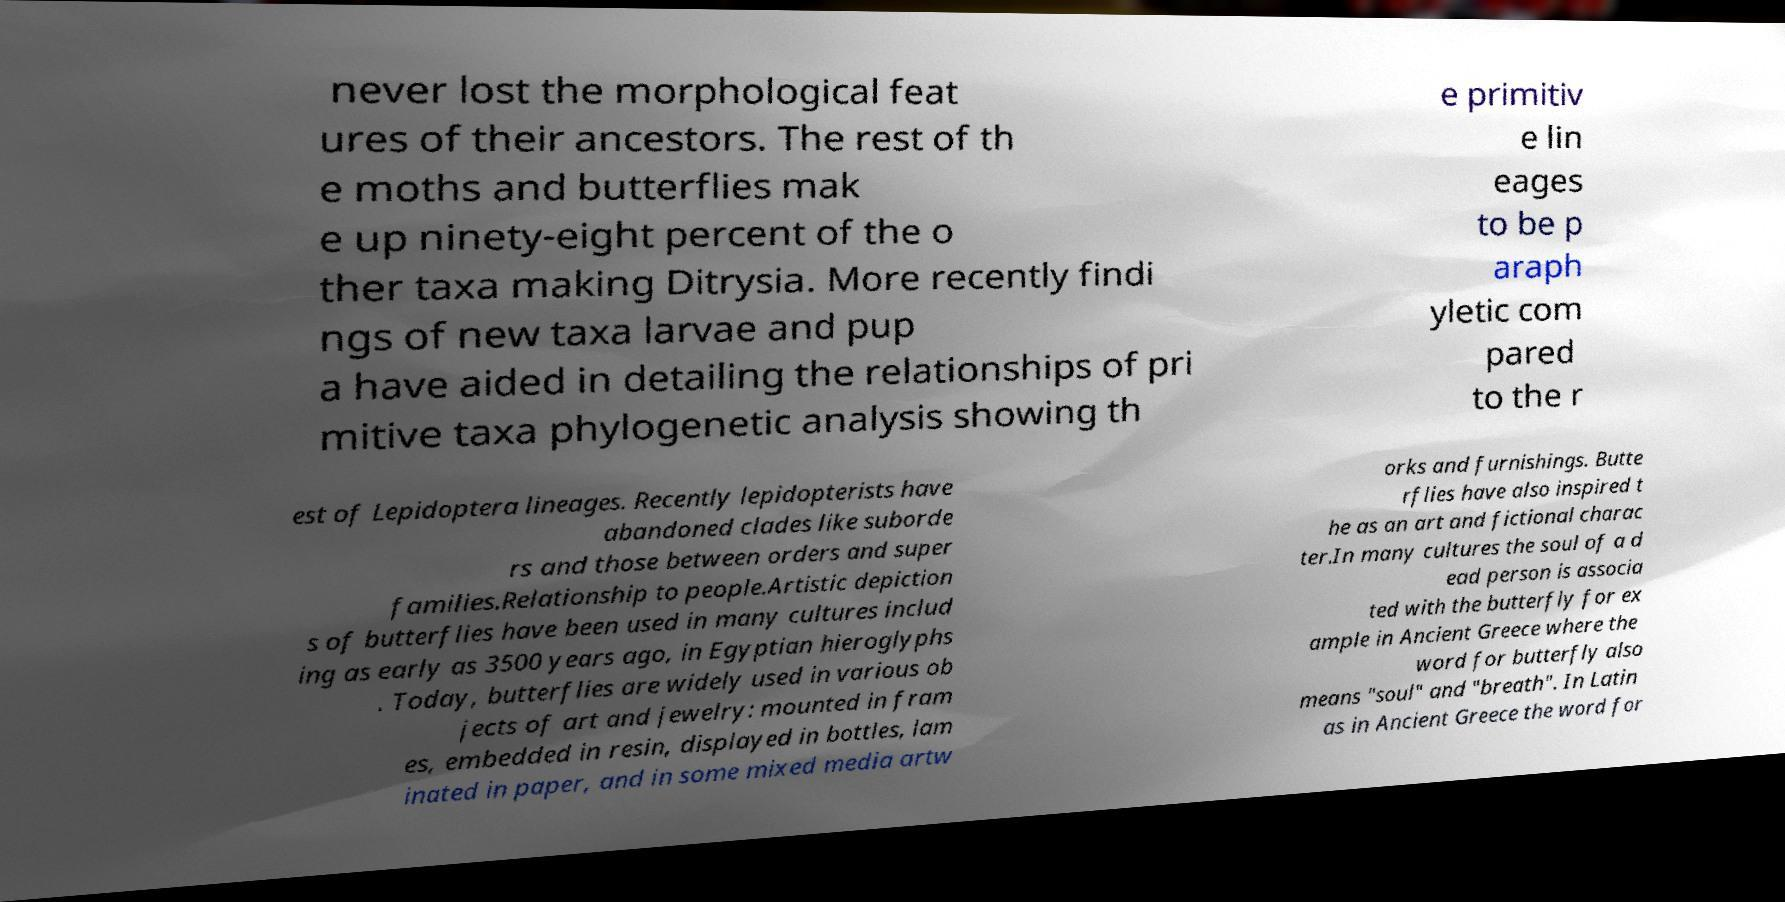Please read and relay the text visible in this image. What does it say? never lost the morphological feat ures of their ancestors. The rest of th e moths and butterflies mak e up ninety-eight percent of the o ther taxa making Ditrysia. More recently findi ngs of new taxa larvae and pup a have aided in detailing the relationships of pri mitive taxa phylogenetic analysis showing th e primitiv e lin eages to be p araph yletic com pared to the r est of Lepidoptera lineages. Recently lepidopterists have abandoned clades like suborde rs and those between orders and super families.Relationship to people.Artistic depiction s of butterflies have been used in many cultures includ ing as early as 3500 years ago, in Egyptian hieroglyphs . Today, butterflies are widely used in various ob jects of art and jewelry: mounted in fram es, embedded in resin, displayed in bottles, lam inated in paper, and in some mixed media artw orks and furnishings. Butte rflies have also inspired t he as an art and fictional charac ter.In many cultures the soul of a d ead person is associa ted with the butterfly for ex ample in Ancient Greece where the word for butterfly also means "soul" and "breath". In Latin as in Ancient Greece the word for 